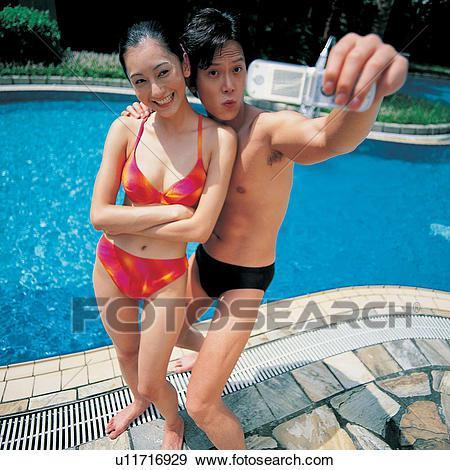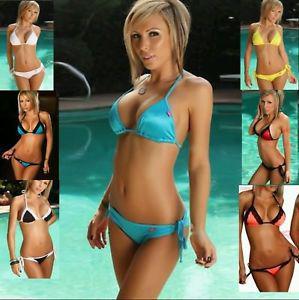The first image is the image on the left, the second image is the image on the right. For the images displayed, is the sentence "Four models in solid-colored bikinis are sitting on the edge of a pool dipping their toes in the water." factually correct? Answer yes or no. No. The first image is the image on the left, the second image is the image on the right. Examine the images to the left and right. Is the description "The left image contains exactly one person in the water." accurate? Answer yes or no. No. 